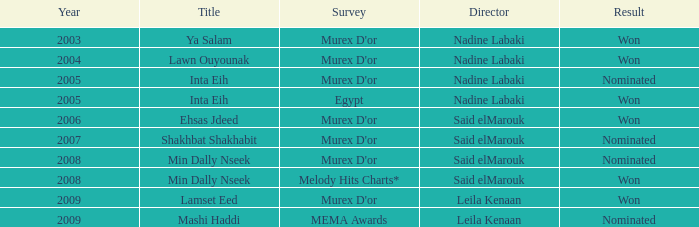What survey has the Ehsas Jdeed title? Murex D'or. 